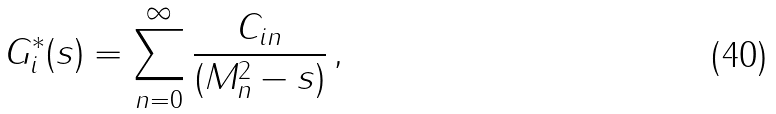<formula> <loc_0><loc_0><loc_500><loc_500>G ^ { * } _ { i } ( s ) = \sum _ { n = 0 } ^ { \infty } \frac { C _ { i n } } { ( M _ { n } ^ { 2 } - s ) } \, ,</formula> 